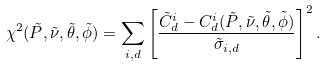Convert formula to latex. <formula><loc_0><loc_0><loc_500><loc_500>\chi ^ { 2 } ( \tilde { P } , \tilde { \nu } , \tilde { \theta } , \tilde { \phi } ) = \sum _ { i , d } \left [ \frac { \tilde { C } ^ { i } _ { d } - C ^ { i } _ { d } ( \tilde { P } , \tilde { \nu } , \tilde { \theta } , \tilde { \phi } ) } { \tilde { \sigma } _ { i , d } } \right ] ^ { 2 } .</formula> 